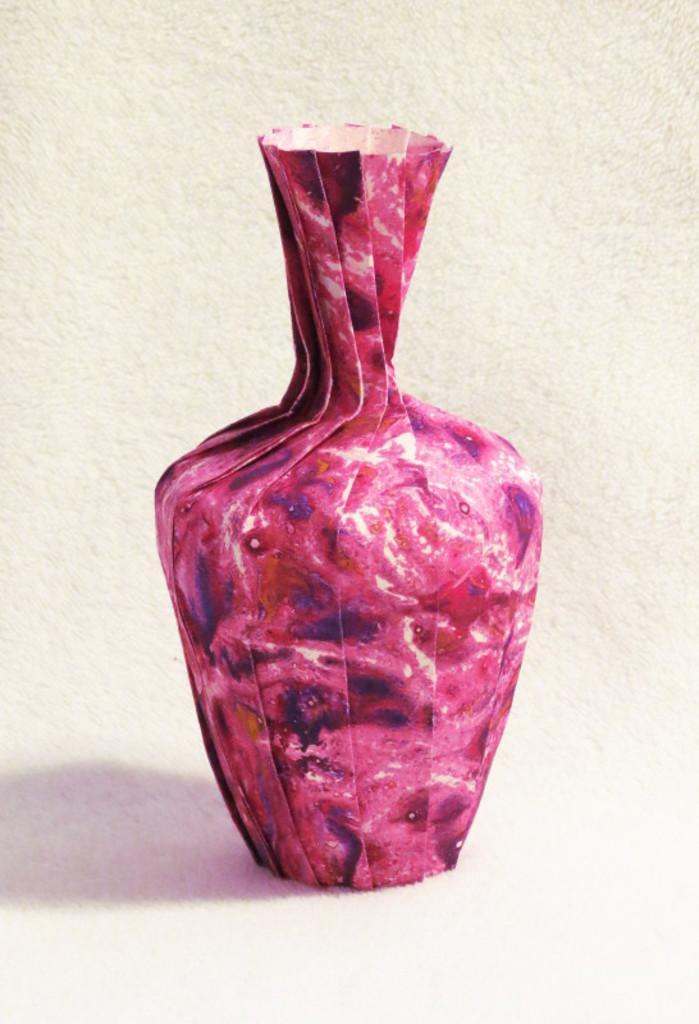Please provide a concise description of this image. In this picture we can see a vase and this is carpet. 